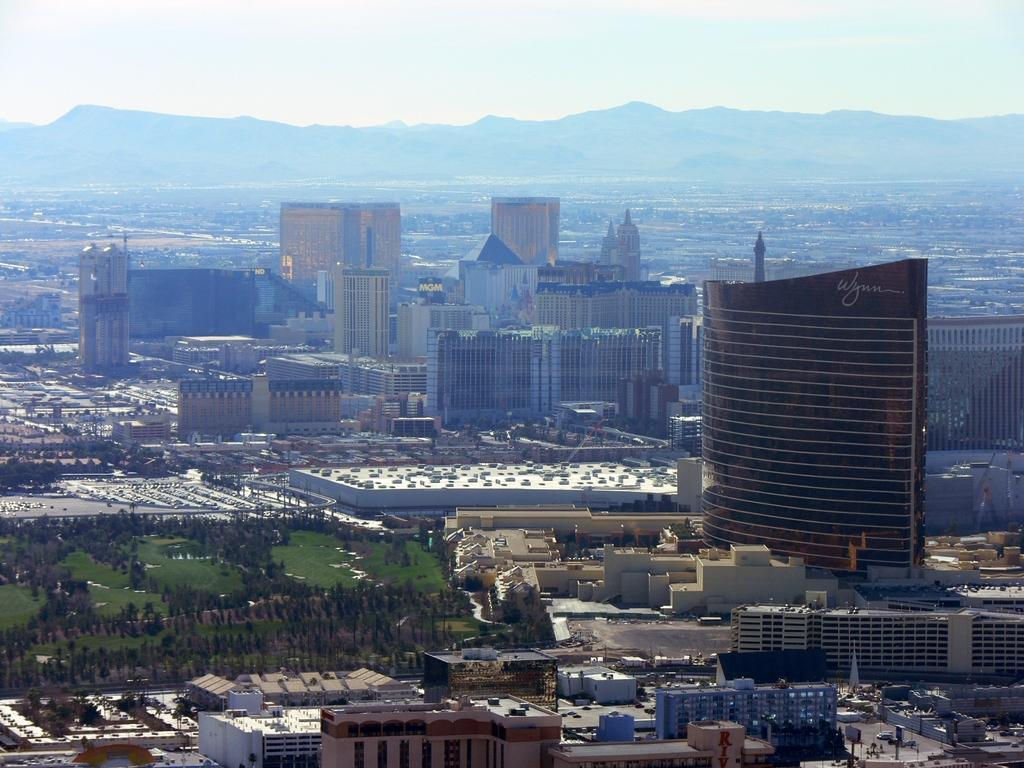How would you summarize this image in a sentence or two? We can see buildings, trees, grass, vehicles and boards on poles. In the background we can see hills and sky. 